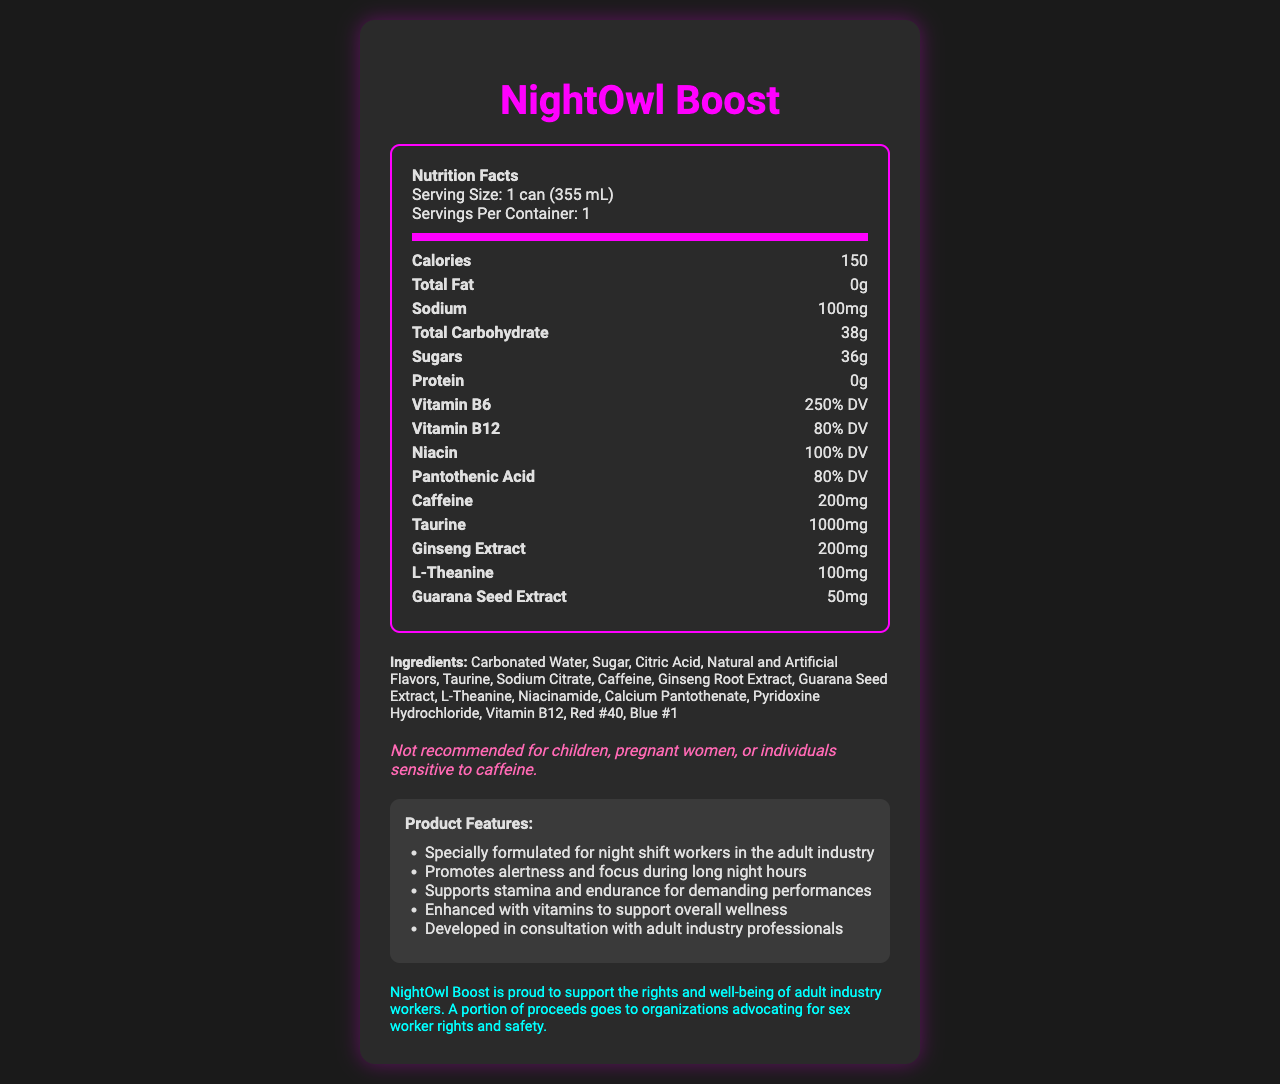1. What is the serving size of NightOwl Boost? According to the nutrition label, the serving size is listed as "1 can (355 mL)".
Answer: 1 can (355 mL) 2. How much caffeine does one serving of NightOwl Boost contain? The nutrition facts indicate that one serving contains 200mg of caffeine.
Answer: 200mg 3. Which vitamins are included in NightOwl Boost, and what are their daily values (DV)? The nutrition label lists the vitamins contained, along with their respective daily values: Vitamin B6 (250% DV), Vitamin B12 (80% DV), Niacin (100% DV), and Pantothenic Acid (80% DV).
Answer: Vitamin B6 (250% DV), Vitamin B12 (80% DV), Niacin (100% DV), Pantothenic Acid (80% DV) 4. What is the total carbohydrate content in one serving of NightOwl Boost? The nutrition label specifies that the total carbohydrate content is 38g.
Answer: 38g 5. What is unique about NightOwl Boost regarding its target consumers? The marketing claims section states that the product is specially formulated for night shift workers in the adult industry.
Answer: Specially formulated for night shift workers in the adult industry 6. Does NightOwl Boost contain any protein? The nutrition facts indicate that the protein content of NightOwl Boost is 0g.
Answer: No 7. What are the two highest non-vitamin ingredients by quantity in NightOwl Boost? A. Taurine and Ginseng Extract B. Taurine and Caffeine C. Caffeine and Ginseng Extract D. L-Theanine and Guarana Seed Extract The nutrition facts show that Taurine is 1000mg and Caffeine is 200mg, which are the highest non-vitamin ingredients.
Answer: B. Taurine and Caffeine 8. Which of the following ingredients is not listed in NightOwl Boost? I. Aspartame II. Red #40 III. Sodium Citrate Under the ingredients list, Aspartame is not mentioned, while Red #40 and Sodium Citrate are included.
Answer: I. Aspartame 9. Can NightOwl Boost be recommended for pregnant women? The disclaimer explicitly states that it is not recommended for pregnant women.
Answer: No 10. Is there any allergen information provided for NightOwl Boost? The allergen information indicates that it is produced in a facility that also processes soy and milk products.
Answer: Yes 11. Summarize the main purpose and key elements of the NightOwl Boost Nutrition Facts document. The document covers nutrition facts, ingredients, and specific claims about the product, emphasizing its suitability for those working night shifts in the adult industry. It also mentions the product's purpose and advocacy for sex worker rights.
Answer: The document provides detailed nutritional information and marketing claims for NightOwl Boost, an energy drink. It highlights the serving size, calories, and nutritional content, including high levels of caffeine, taurine, and various vitamins. The drink is formulated for night shift workers in the adult industry, aiming to promote alertness and stamina. It also includes ingredients, allergen information, a disclaimer for sensitive individuals, and a note of support for adult industry workers. 12. What percentage of the daily value of Vitamin B12 does NightOwl Boost provide? The nutrition label shows that Vitamin B12 is provided at 80% of the daily value.
Answer: 80% DV 13. How many grams of sugars are in one can of NightOwl Boost? According to the nutrition facts, one can contains 36g of sugars.
Answer: 36g 14. What kind of impact does NightOwl Boost claim to have on stamina and endurance? The marketing claims state that the drink supports stamina and endurance for demanding performances, which is essential for night shift workers.
Answer: Supports stamina and endurance for demanding performances 15. Is the company Nocturnal Vitality Beverages, LLC associated with any social causes according to the document? The additional information indicates that a portion of the proceeds goes to organizations advocating for sex worker rights and safety.
Answer: Yes 16. Are there artificial colors in NightOwl Boost? If so, which ones? The ingredients list includes artificial colors Red #40 and Blue #1.
Answer: Yes, Red #40 and Blue #1 17. Which ingredient is present in the highest amount? The nutrition facts indicate that Taurine is present in the highest amount at 1000mg.
Answer: Taurine 18. What is the sodium content in one serving of NightOwl Boost? A. 50mg B. 100mg C. 200mg D. 150mg The nutrition label specifies that the sodium content is 100mg per serving.
Answer: B. 100mg 19. Does NightOwl Boost provide any health benefits beyond energy? While the drink is formulated to promote alertness and stamina, the label does not provide enough detailed information on specific health benefits beyond energy and vitamin supplementation.
Answer: Not enough information 20. What portion of proceeds does the NightOwl Boost brand allocate to social causes? The document mentions that a portion of proceeds goes to organizations advocating for sex worker rights and safety, but the specific portion is not mentioned.
Answer: Not specified 